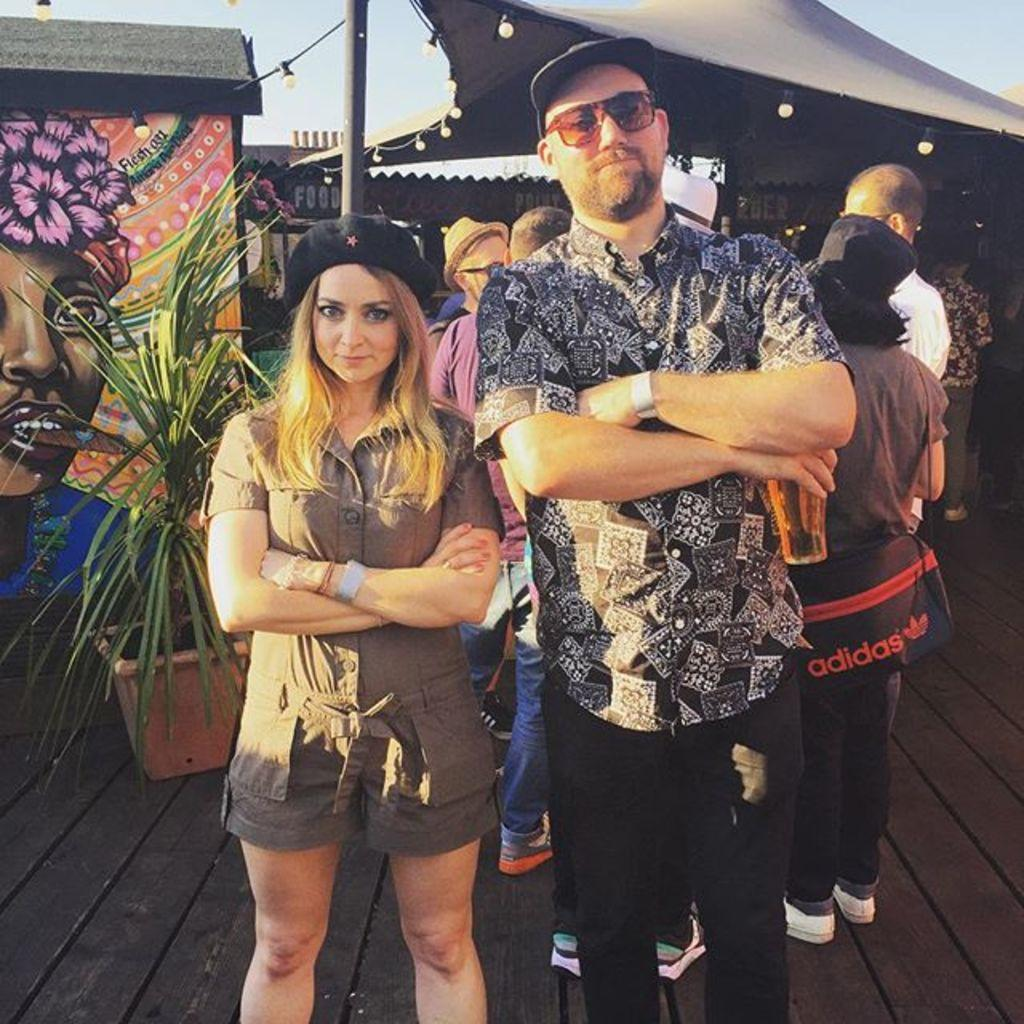What is happening in the middle of the image? There is a group of persons standing in the middle of the image. What can be seen on the left side of the image? There is a wall and a plant on the left side of the image. What is visible in the background of the image? There is a tent in the background of the image. What color is the shirt worn by the bee in the image? There is no bee present in the image, and therefore no shirt worn by a bee can be observed. 